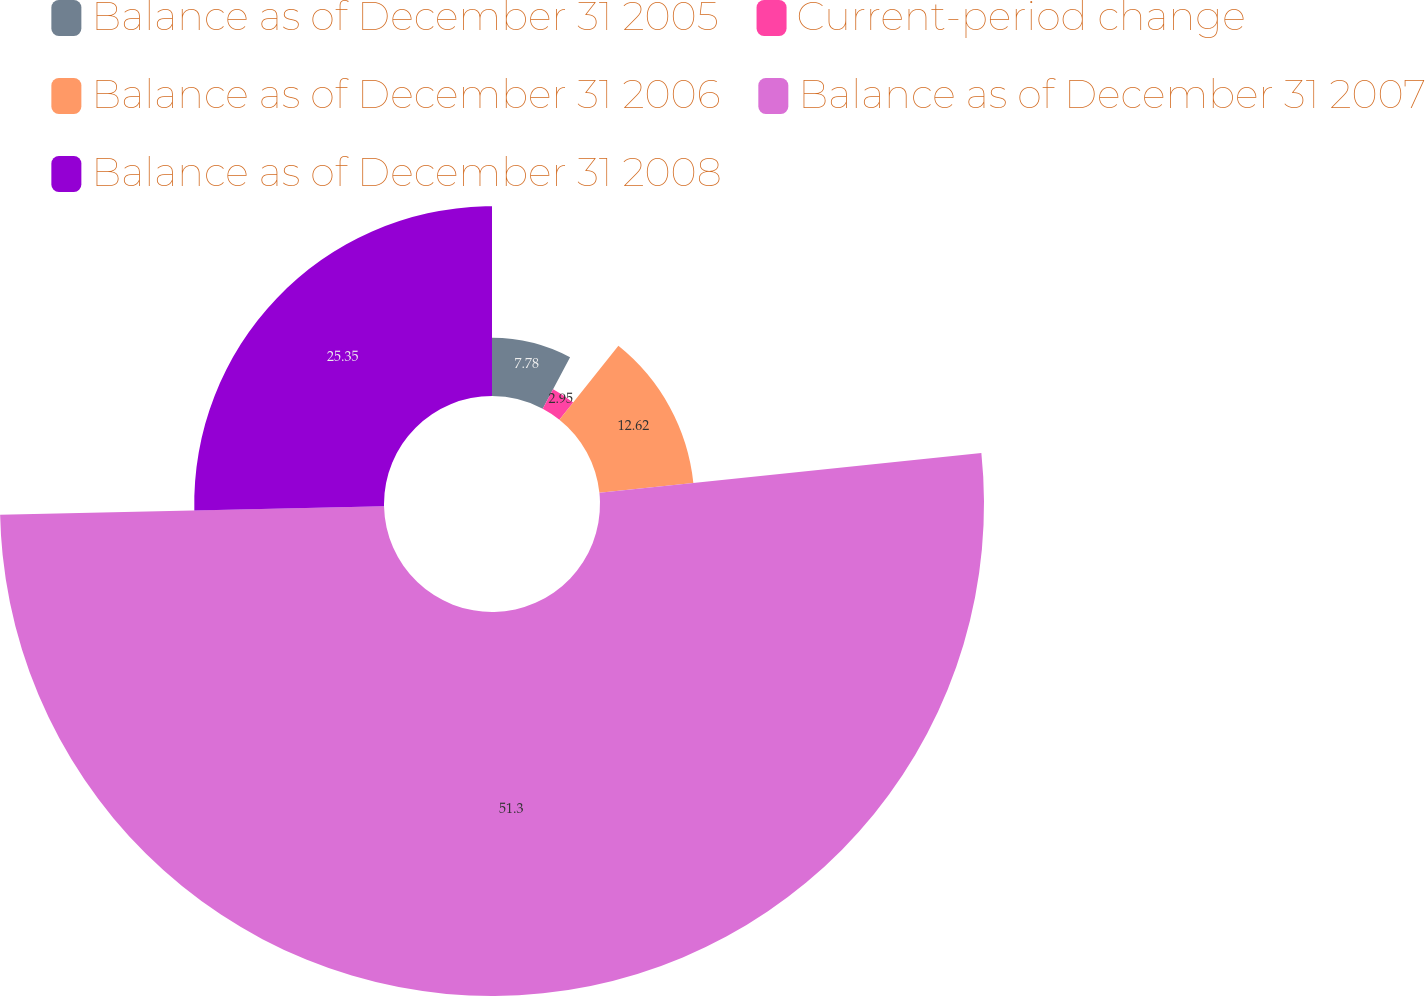<chart> <loc_0><loc_0><loc_500><loc_500><pie_chart><fcel>Balance as of December 31 2005<fcel>Current-period change<fcel>Balance as of December 31 2006<fcel>Balance as of December 31 2007<fcel>Balance as of December 31 2008<nl><fcel>7.78%<fcel>2.95%<fcel>12.62%<fcel>51.3%<fcel>25.35%<nl></chart> 